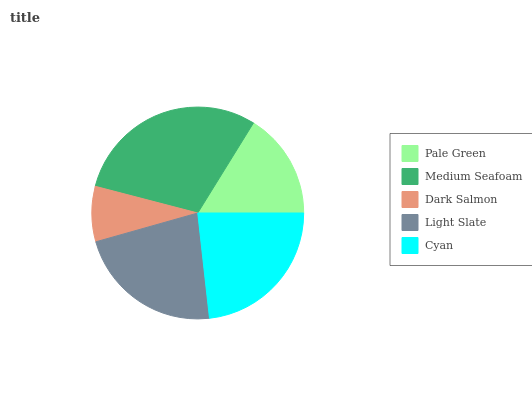Is Dark Salmon the minimum?
Answer yes or no. Yes. Is Medium Seafoam the maximum?
Answer yes or no. Yes. Is Medium Seafoam the minimum?
Answer yes or no. No. Is Dark Salmon the maximum?
Answer yes or no. No. Is Medium Seafoam greater than Dark Salmon?
Answer yes or no. Yes. Is Dark Salmon less than Medium Seafoam?
Answer yes or no. Yes. Is Dark Salmon greater than Medium Seafoam?
Answer yes or no. No. Is Medium Seafoam less than Dark Salmon?
Answer yes or no. No. Is Light Slate the high median?
Answer yes or no. Yes. Is Light Slate the low median?
Answer yes or no. Yes. Is Dark Salmon the high median?
Answer yes or no. No. Is Pale Green the low median?
Answer yes or no. No. 